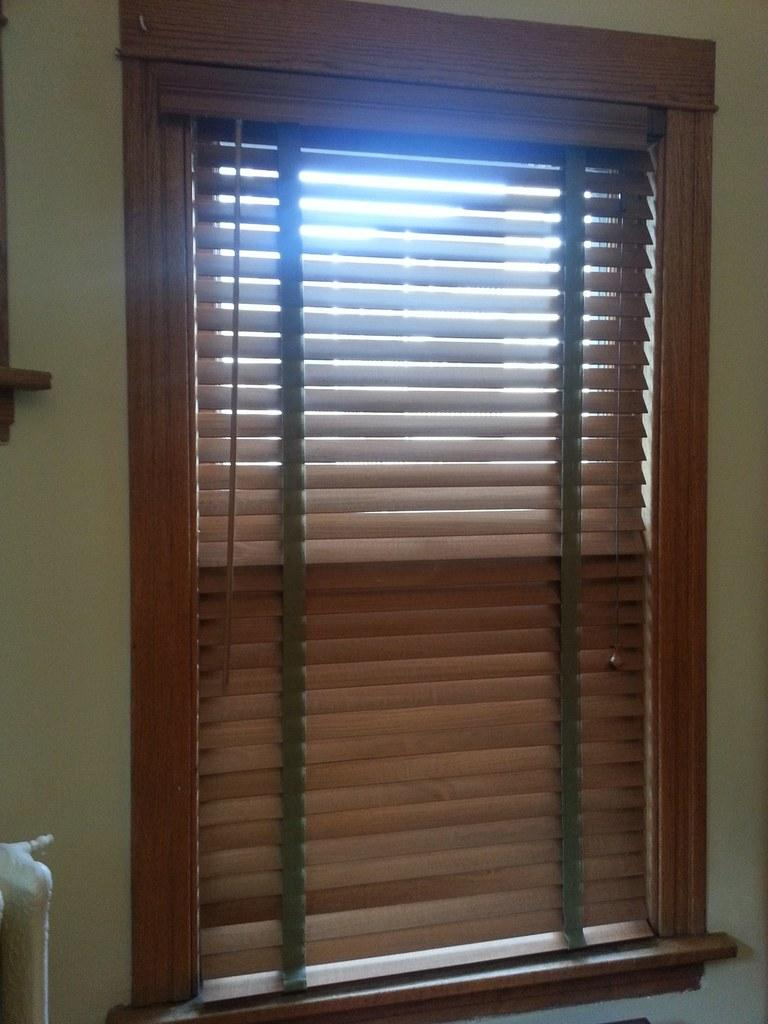What type of window is visible in the image? There is a wooden window in the image. What feature is present on the wooden window? The wooden window has brown blinds. How many books does the carpenter's aunt have on her bookshelf in the image? There is no carpenter, aunt, or bookshelf present in the image. 